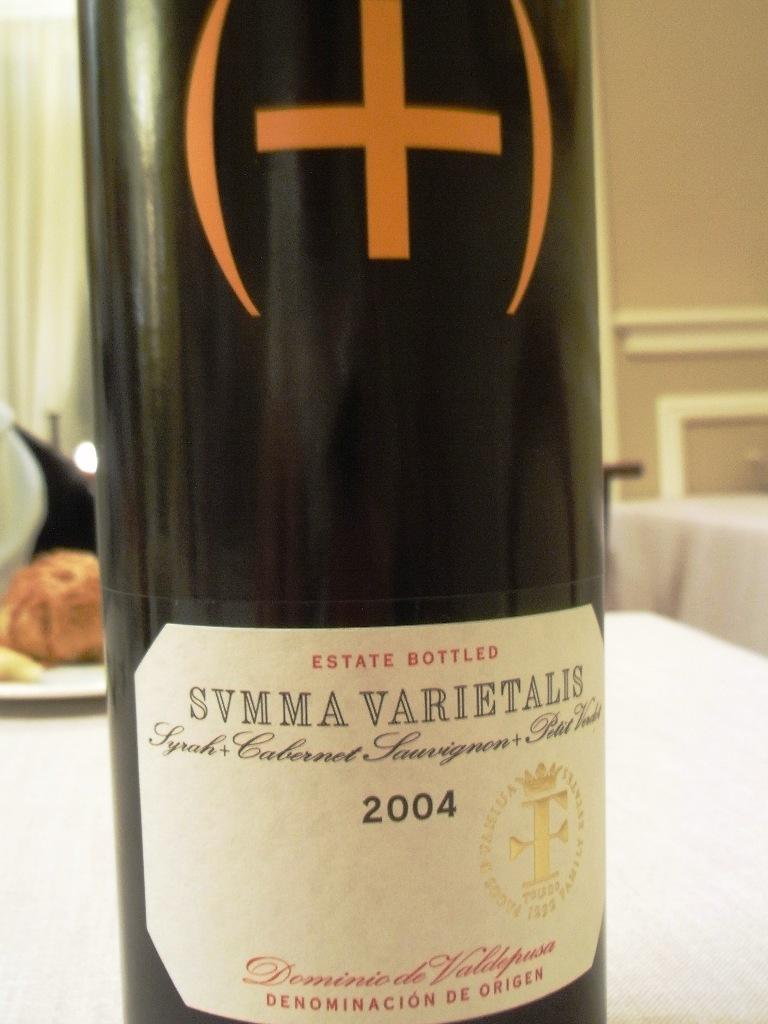<image>
Summarize the visual content of the image. A bottle of SVMMA VARIETALIS wine from 2004 is displayed on a table. 